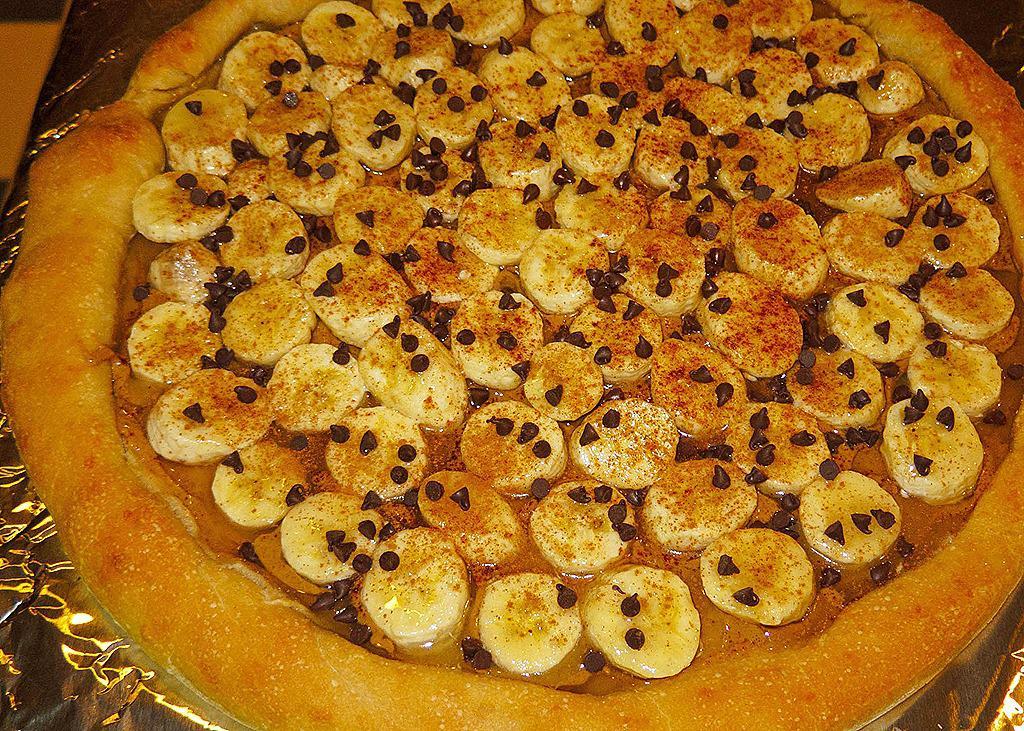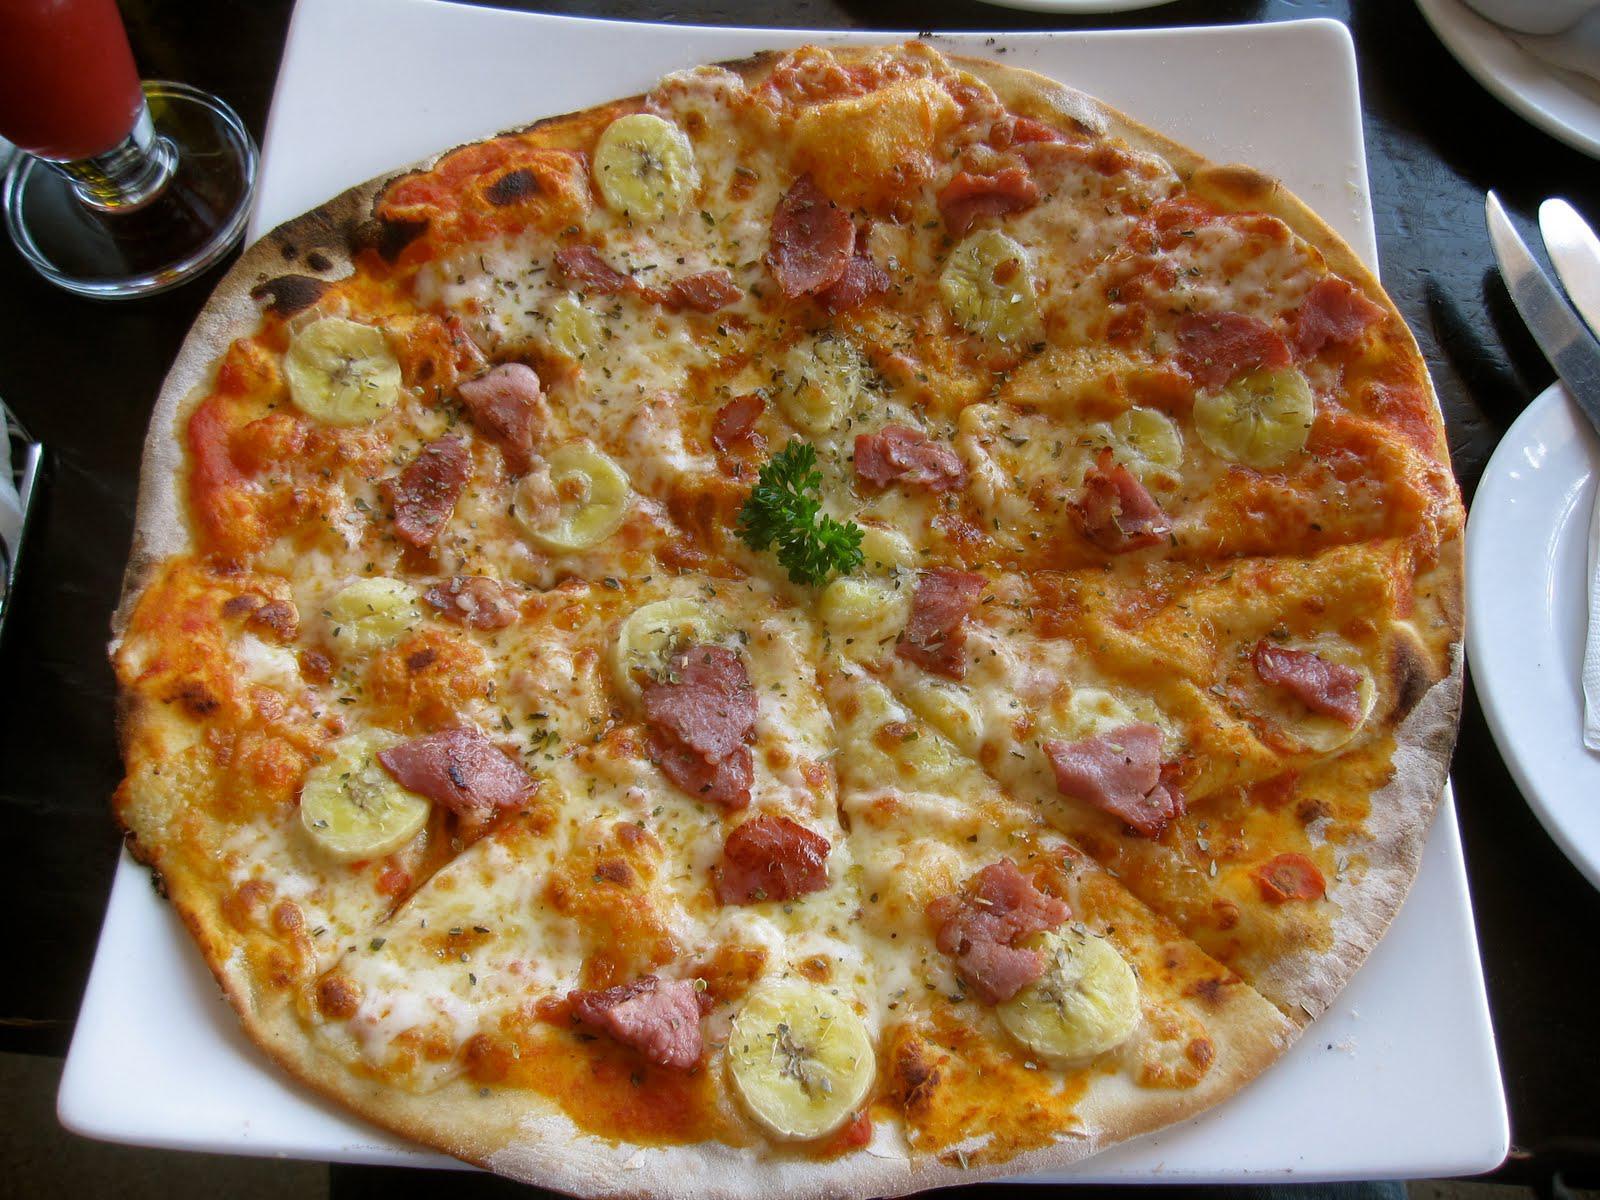The first image is the image on the left, the second image is the image on the right. Analyze the images presented: Is the assertion "One image shows a pizza served on a white platter." valid? Answer yes or no. Yes. 